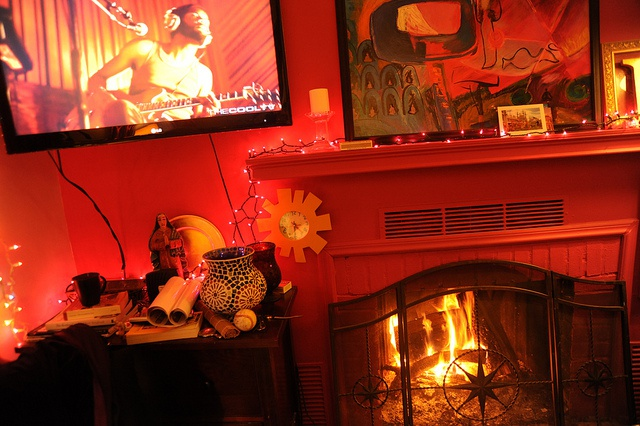Describe the objects in this image and their specific colors. I can see tv in salmon, black, and ivory tones, people in red, beige, orange, salmon, and khaki tones, vase in red, maroon, black, and brown tones, book in red, brown, and maroon tones, and cup in red, black, maroon, and brown tones in this image. 